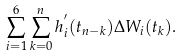<formula> <loc_0><loc_0><loc_500><loc_500>\sum _ { i = 1 } ^ { 6 } \sum _ { k = 0 } ^ { n } h ^ { ^ { \prime } } _ { i } ( t _ { n - k } ) \Delta W _ { i } ( t _ { k } ) .</formula> 